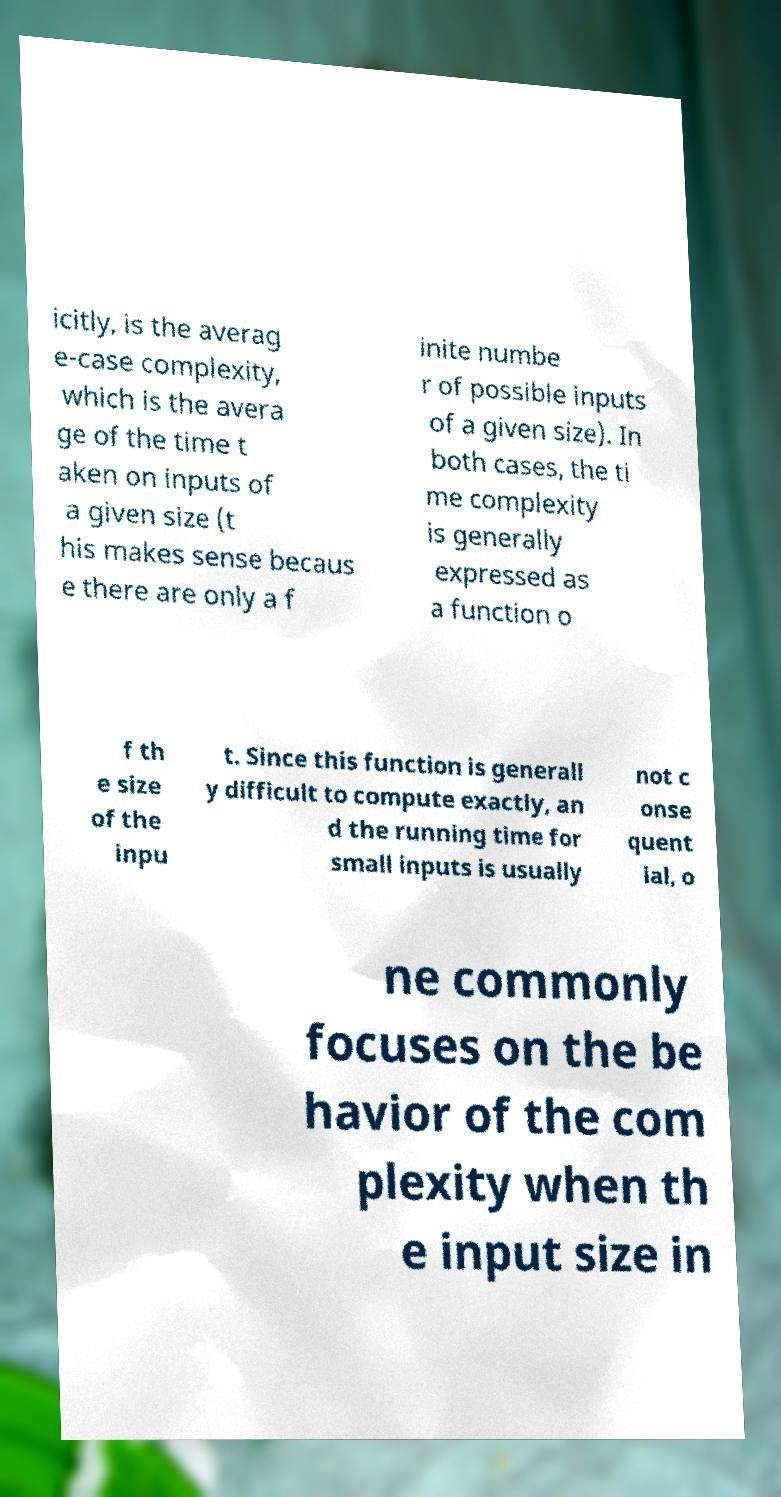Please identify and transcribe the text found in this image. icitly, is the averag e-case complexity, which is the avera ge of the time t aken on inputs of a given size (t his makes sense becaus e there are only a f inite numbe r of possible inputs of a given size). In both cases, the ti me complexity is generally expressed as a function o f th e size of the inpu t. Since this function is generall y difficult to compute exactly, an d the running time for small inputs is usually not c onse quent ial, o ne commonly focuses on the be havior of the com plexity when th e input size in 